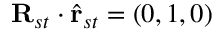Convert formula to latex. <formula><loc_0><loc_0><loc_500><loc_500>R _ { s t } \cdot \hat { r } _ { s t } = ( 0 , 1 , 0 )</formula> 